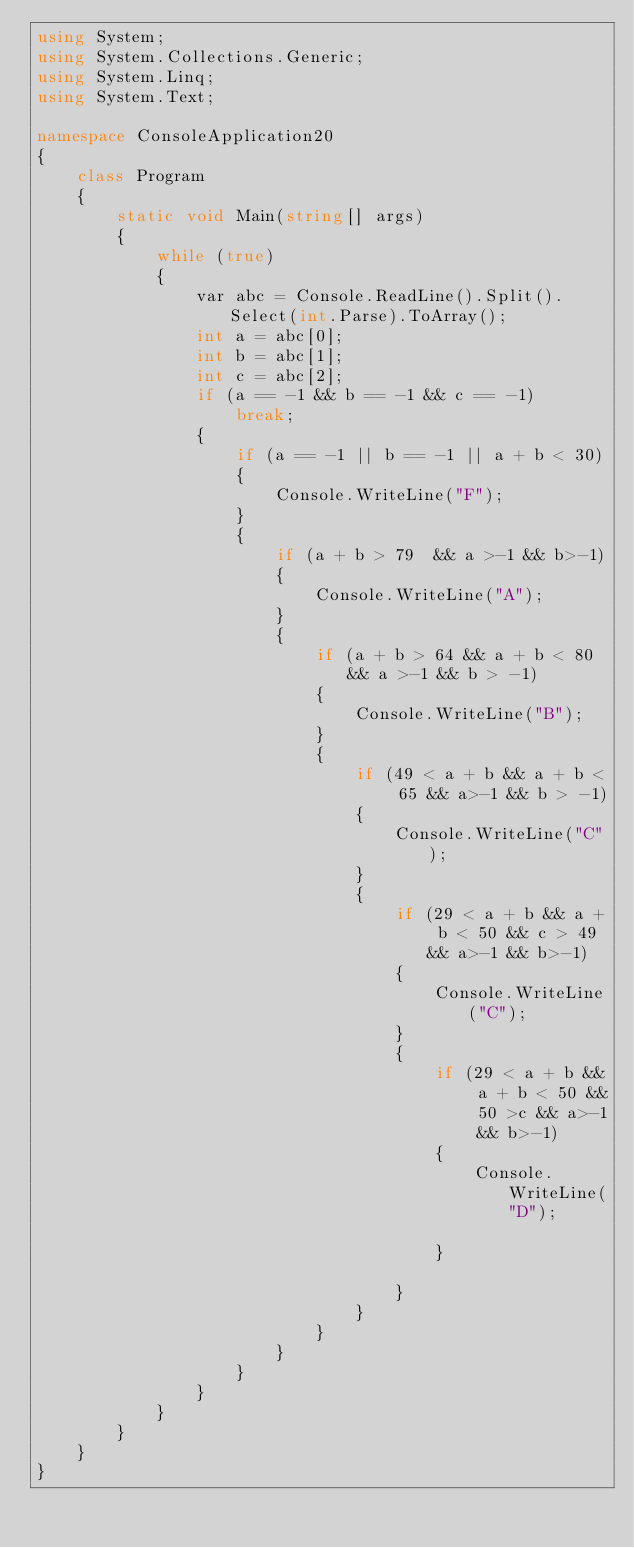Convert code to text. <code><loc_0><loc_0><loc_500><loc_500><_C#_>using System;
using System.Collections.Generic;
using System.Linq;
using System.Text;

namespace ConsoleApplication20
{
    class Program
    {
        static void Main(string[] args)
        {
            while (true)
            {
                var abc = Console.ReadLine().Split().Select(int.Parse).ToArray();
                int a = abc[0];
                int b = abc[1];
                int c = abc[2];
                if (a == -1 && b == -1 && c == -1)
                    break;
                {
                    if (a == -1 || b == -1 || a + b < 30)
                    {
                        Console.WriteLine("F");
                    }
                    {
                        if (a + b > 79  && a >-1 && b>-1)
                        {
                            Console.WriteLine("A");
                        }
                        {
                            if (a + b > 64 && a + b < 80 && a >-1 && b > -1)
                            {
                                Console.WriteLine("B");
                            }
                            {
                                if (49 < a + b && a + b < 65 && a>-1 && b > -1)
                                {
                                    Console.WriteLine("C");
                                }
                                {
                                    if (29 < a + b && a + b < 50 && c > 49 && a>-1 && b>-1)
                                    {
                                        Console.WriteLine("C");
                                    }
                                    {
                                        if (29 < a + b && a + b < 50 && 50 >c && a>-1 && b>-1)
                                        {
                                            Console.WriteLine("D");

                                        }

                                    }
                                }
                            }
                        }
                    }
                }
            }
        }
    }
}</code> 